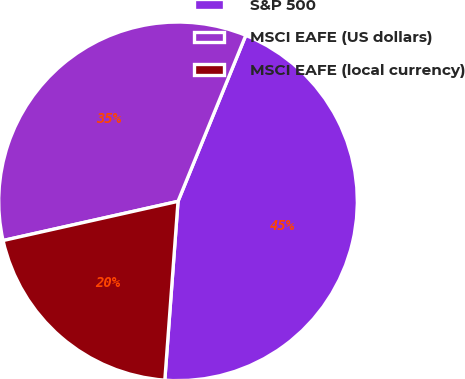Convert chart. <chart><loc_0><loc_0><loc_500><loc_500><pie_chart><fcel>S&P 500<fcel>MSCI EAFE (US dollars)<fcel>MSCI EAFE (local currency)<nl><fcel>45.01%<fcel>34.68%<fcel>20.32%<nl></chart> 